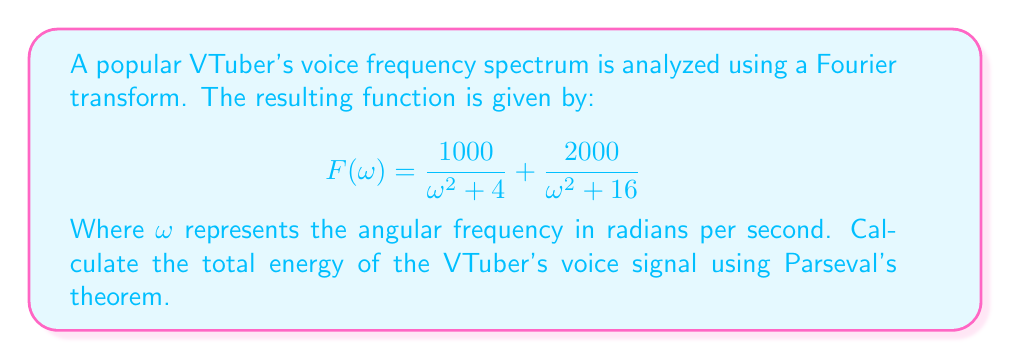Show me your answer to this math problem. To solve this problem, we'll use Parseval's theorem, which states that the total energy of a signal is equal to the integral of the square of its Fourier transform over all frequencies, divided by $2\pi$. 

Step 1: Write out Parseval's theorem
$$E = \frac{1}{2\pi} \int_{-\infty}^{\infty} |F(\omega)|^2 d\omega$$

Step 2: Square the given Fourier transform
$$|F(\omega)|^2 = \left(\frac{1000}{\omega^2 + 4} + \frac{2000}{\omega^2 + 16}\right)^2$$

Step 3: Expand the squared term
$$|F(\omega)|^2 = \frac{1000000}{(\omega^2 + 4)^2} + \frac{4000000}{(\omega^2 + 16)^2} + \frac{4000000}{(\omega^2 + 4)(\omega^2 + 16)}$$

Step 4: Set up the integral
$$E = \frac{1}{2\pi} \int_{-\infty}^{\infty} \left(\frac{1000000}{(\omega^2 + 4)^2} + \frac{4000000}{(\omega^2 + 16)^2} + \frac{4000000}{(\omega^2 + 4)(\omega^2 + 16)}\right) d\omega$$

Step 5: Use partial fraction decomposition and standard integral formulas to evaluate each term

For the first term: $\int_{-\infty}^{\infty} \frac{1}{(\omega^2 + a^2)^2} d\omega = \frac{\pi}{2a^3}$
$$\frac{1000000}{2\pi} \cdot \frac{\pi}{2 \cdot 2^3} = 31250$$

For the second term: $\int_{-\infty}^{\infty} \frac{1}{(\omega^2 + a^2)^2} d\omega = \frac{\pi}{2a^3}$
$$\frac{4000000}{2\pi} \cdot \frac{\pi}{2 \cdot 4^3} = 15625$$

For the third term: $\int_{-\infty}^{\infty} \frac{1}{(\omega^2 + a^2)(\omega^2 + b^2)} d\omega = \frac{\pi}{a^2 - b^2}(\frac{1}{a} - \frac{1}{b})$
$$\frac{4000000}{2\pi} \cdot \frac{\pi}{4^2 - 2^2}(\frac{1}{4} - \frac{1}{2}) = 125000$$

Step 6: Sum all terms to get the total energy
$$E = 31250 + 15625 + 125000 = 171875$$
Answer: 171875 